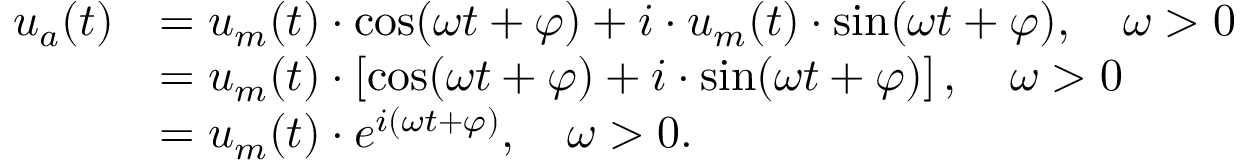Convert formula to latex. <formula><loc_0><loc_0><loc_500><loc_500>{ \begin{array} { r l } { u _ { a } ( t ) } & { = u _ { m } ( t ) \cdot \cos ( \omega t + \varphi ) + i \cdot u _ { m } ( t ) \cdot \sin ( \omega t + \varphi ) , \quad \omega > 0 } \\ & { = u _ { m } ( t ) \cdot \left [ \cos ( \omega t + \varphi ) + i \cdot \sin ( \omega t + \varphi ) \right ] , \quad \omega > 0 } \\ & { = u _ { m } ( t ) \cdot e ^ { i ( \omega t + \varphi ) } , \quad \omega > 0 . \, } \end{array} }</formula> 